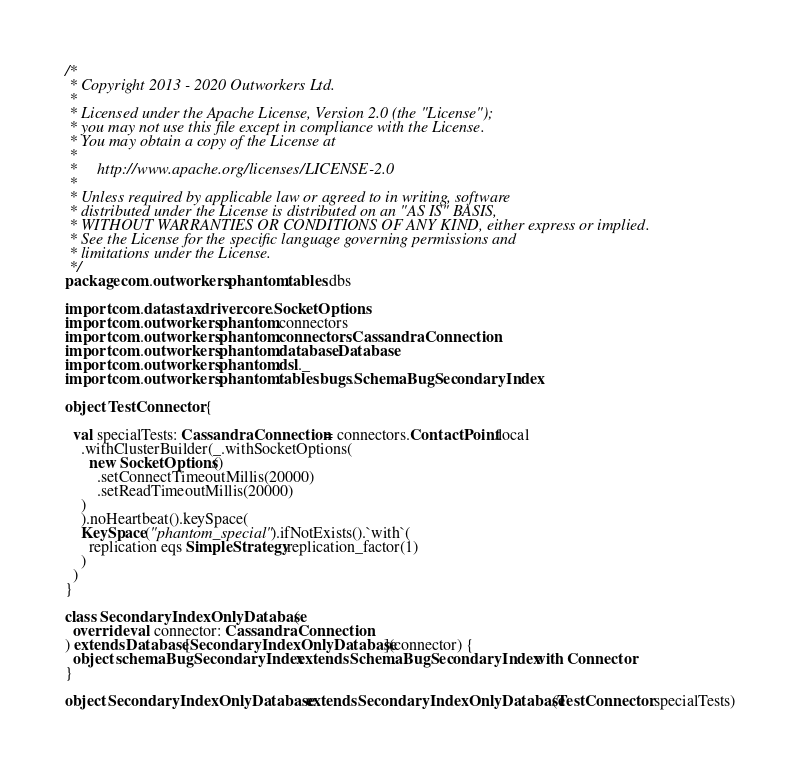<code> <loc_0><loc_0><loc_500><loc_500><_Scala_>/*
 * Copyright 2013 - 2020 Outworkers Ltd.
 *
 * Licensed under the Apache License, Version 2.0 (the "License");
 * you may not use this file except in compliance with the License.
 * You may obtain a copy of the License at
 *
 *     http://www.apache.org/licenses/LICENSE-2.0
 *
 * Unless required by applicable law or agreed to in writing, software
 * distributed under the License is distributed on an "AS IS" BASIS,
 * WITHOUT WARRANTIES OR CONDITIONS OF ANY KIND, either express or implied.
 * See the License for the specific language governing permissions and
 * limitations under the License.
 */
package com.outworkers.phantom.tables.dbs

import com.datastax.driver.core.SocketOptions
import com.outworkers.phantom.connectors
import com.outworkers.phantom.connectors.CassandraConnection
import com.outworkers.phantom.database.Database
import com.outworkers.phantom.dsl._
import com.outworkers.phantom.tables.bugs.SchemaBugSecondaryIndex

object TestConnector {

  val specialTests: CassandraConnection = connectors.ContactPoint.local
    .withClusterBuilder(_.withSocketOptions(
      new SocketOptions()
        .setConnectTimeoutMillis(20000)
        .setReadTimeoutMillis(20000)
    )
    ).noHeartbeat().keySpace(
    KeySpace("phantom_special").ifNotExists().`with`(
      replication eqs SimpleStrategy.replication_factor(1)
    )
  )
}

class SecondaryIndexOnlyDatabase(
  override val connector: CassandraConnection
) extends Database[SecondaryIndexOnlyDatabase](connector) {
  object schemaBugSecondaryIndex extends SchemaBugSecondaryIndex with Connector
}

object SecondaryIndexOnlyDatabase extends SecondaryIndexOnlyDatabase(TestConnector.specialTests)</code> 